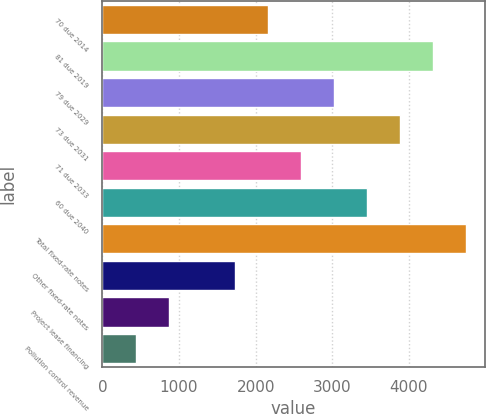Convert chart. <chart><loc_0><loc_0><loc_500><loc_500><bar_chart><fcel>70 due 2014<fcel>81 due 2019<fcel>79 due 2029<fcel>73 due 2031<fcel>71 due 2033<fcel>60 due 2040<fcel>Total fixed-rate notes<fcel>Other fixed-rate notes<fcel>Project lease financing<fcel>Pollution control revenue<nl><fcel>2160.5<fcel>4319<fcel>3023.9<fcel>3887.3<fcel>2592.2<fcel>3455.6<fcel>4750.7<fcel>1728.8<fcel>865.4<fcel>433.7<nl></chart> 